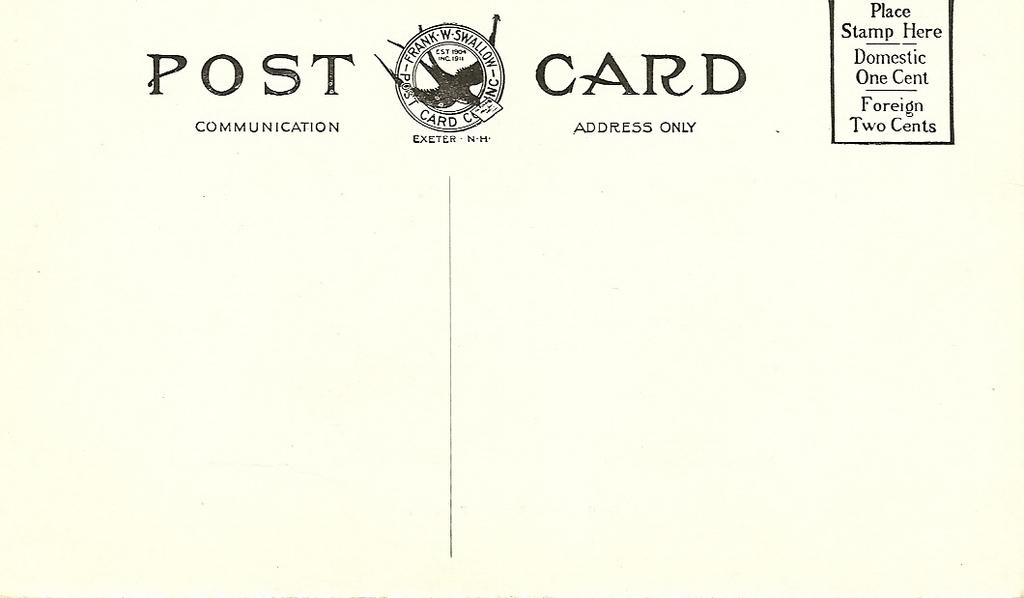<image>
Create a compact narrative representing the image presented. A Frank W Swallow Post Card only needs one cent for domestic stamps 